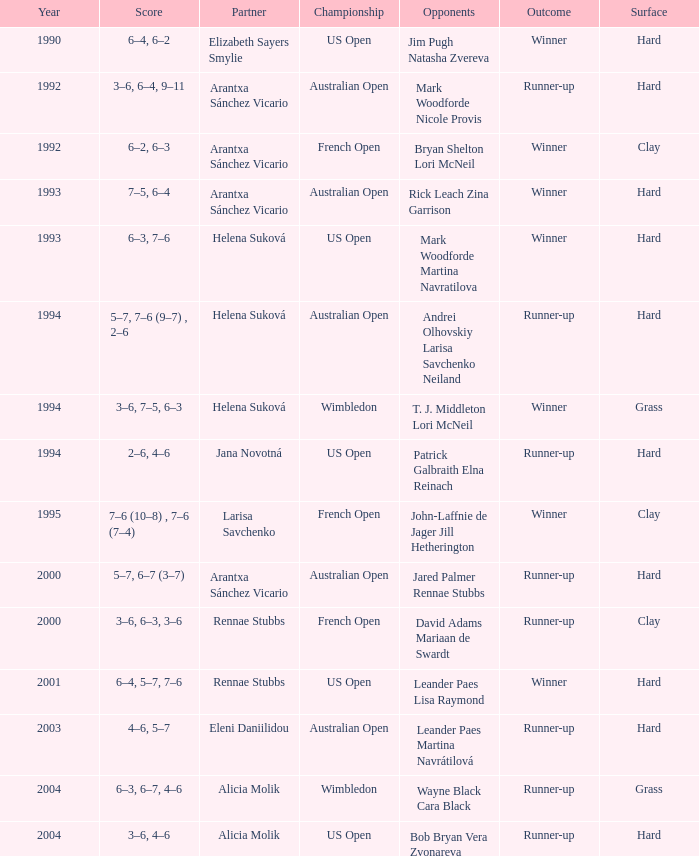Which Score has smaller than 1994, and a Partner of elizabeth sayers smylie? 6–4, 6–2. Would you be able to parse every entry in this table? {'header': ['Year', 'Score', 'Partner', 'Championship', 'Opponents', 'Outcome', 'Surface'], 'rows': [['1990', '6–4, 6–2', 'Elizabeth Sayers Smylie', 'US Open', 'Jim Pugh Natasha Zvereva', 'Winner', 'Hard'], ['1992', '3–6, 6–4, 9–11', 'Arantxa Sánchez Vicario', 'Australian Open', 'Mark Woodforde Nicole Provis', 'Runner-up', 'Hard'], ['1992', '6–2, 6–3', 'Arantxa Sánchez Vicario', 'French Open', 'Bryan Shelton Lori McNeil', 'Winner', 'Clay'], ['1993', '7–5, 6–4', 'Arantxa Sánchez Vicario', 'Australian Open', 'Rick Leach Zina Garrison', 'Winner', 'Hard'], ['1993', '6–3, 7–6', 'Helena Suková', 'US Open', 'Mark Woodforde Martina Navratilova', 'Winner', 'Hard'], ['1994', '5–7, 7–6 (9–7) , 2–6', 'Helena Suková', 'Australian Open', 'Andrei Olhovskiy Larisa Savchenko Neiland', 'Runner-up', 'Hard'], ['1994', '3–6, 7–5, 6–3', 'Helena Suková', 'Wimbledon', 'T. J. Middleton Lori McNeil', 'Winner', 'Grass'], ['1994', '2–6, 4–6', 'Jana Novotná', 'US Open', 'Patrick Galbraith Elna Reinach', 'Runner-up', 'Hard'], ['1995', '7–6 (10–8) , 7–6 (7–4)', 'Larisa Savchenko', 'French Open', 'John-Laffnie de Jager Jill Hetherington', 'Winner', 'Clay'], ['2000', '5–7, 6–7 (3–7)', 'Arantxa Sánchez Vicario', 'Australian Open', 'Jared Palmer Rennae Stubbs', 'Runner-up', 'Hard'], ['2000', '3–6, 6–3, 3–6', 'Rennae Stubbs', 'French Open', 'David Adams Mariaan de Swardt', 'Runner-up', 'Clay'], ['2001', '6–4, 5–7, 7–6', 'Rennae Stubbs', 'US Open', 'Leander Paes Lisa Raymond', 'Winner', 'Hard'], ['2003', '4–6, 5–7', 'Eleni Daniilidou', 'Australian Open', 'Leander Paes Martina Navrátilová', 'Runner-up', 'Hard'], ['2004', '6–3, 6–7, 4–6', 'Alicia Molik', 'Wimbledon', 'Wayne Black Cara Black', 'Runner-up', 'Grass'], ['2004', '3–6, 4–6', 'Alicia Molik', 'US Open', 'Bob Bryan Vera Zvonareva', 'Runner-up', 'Hard']]} 